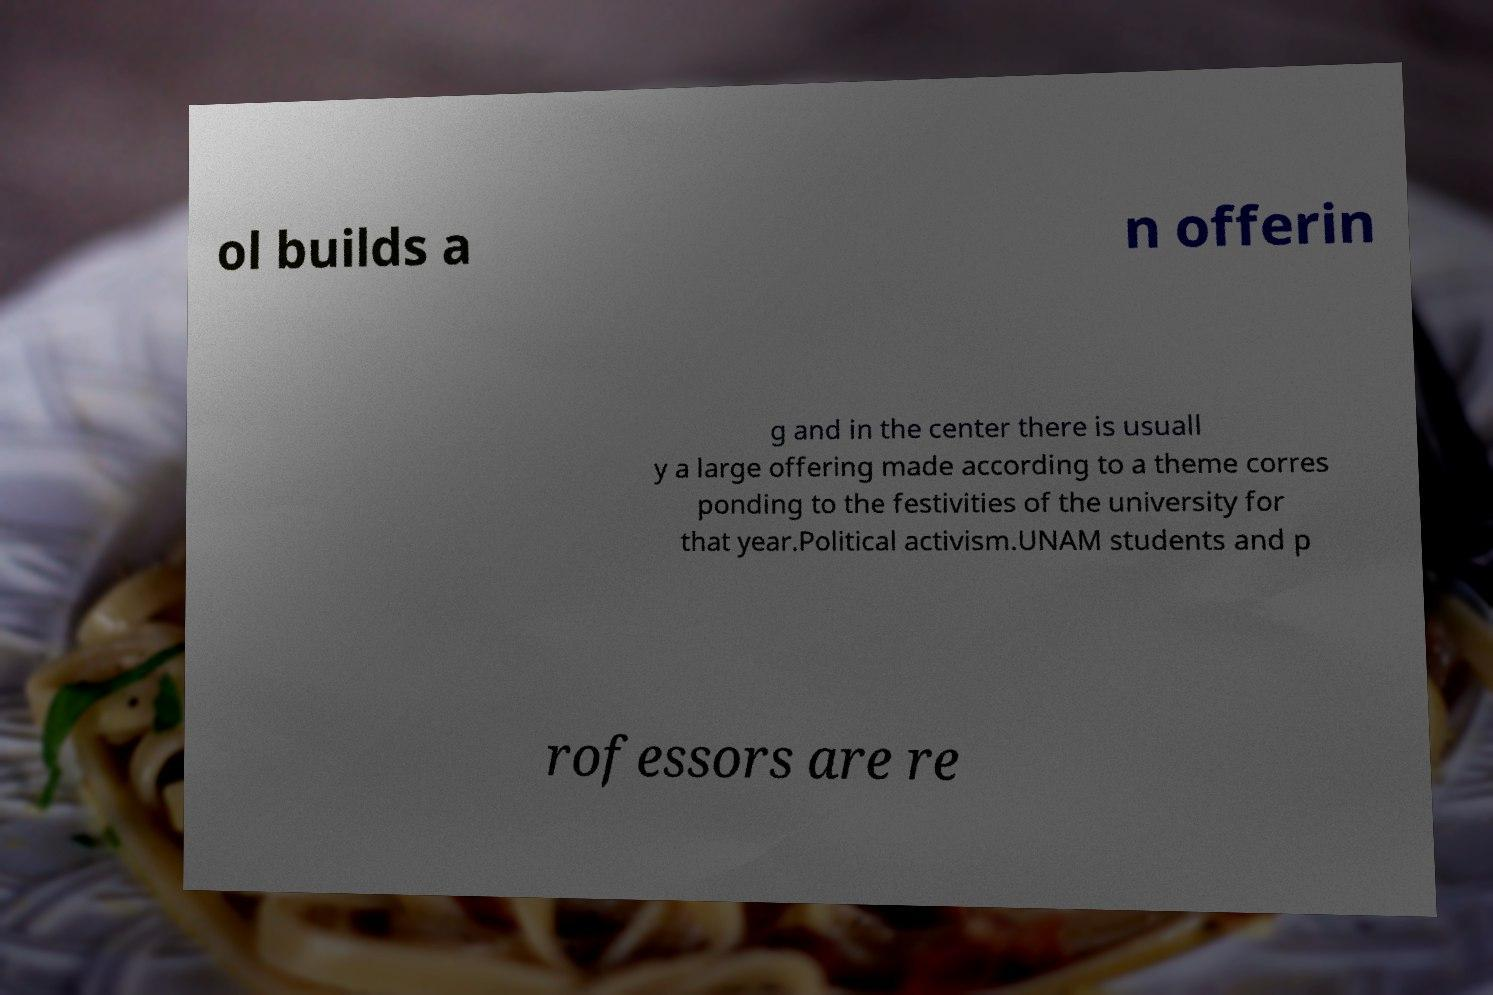For documentation purposes, I need the text within this image transcribed. Could you provide that? ol builds a n offerin g and in the center there is usuall y a large offering made according to a theme corres ponding to the festivities of the university for that year.Political activism.UNAM students and p rofessors are re 